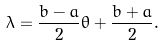<formula> <loc_0><loc_0><loc_500><loc_500>\lambda = \frac { b - a } { 2 } \theta + \frac { b + a } { 2 } .</formula> 